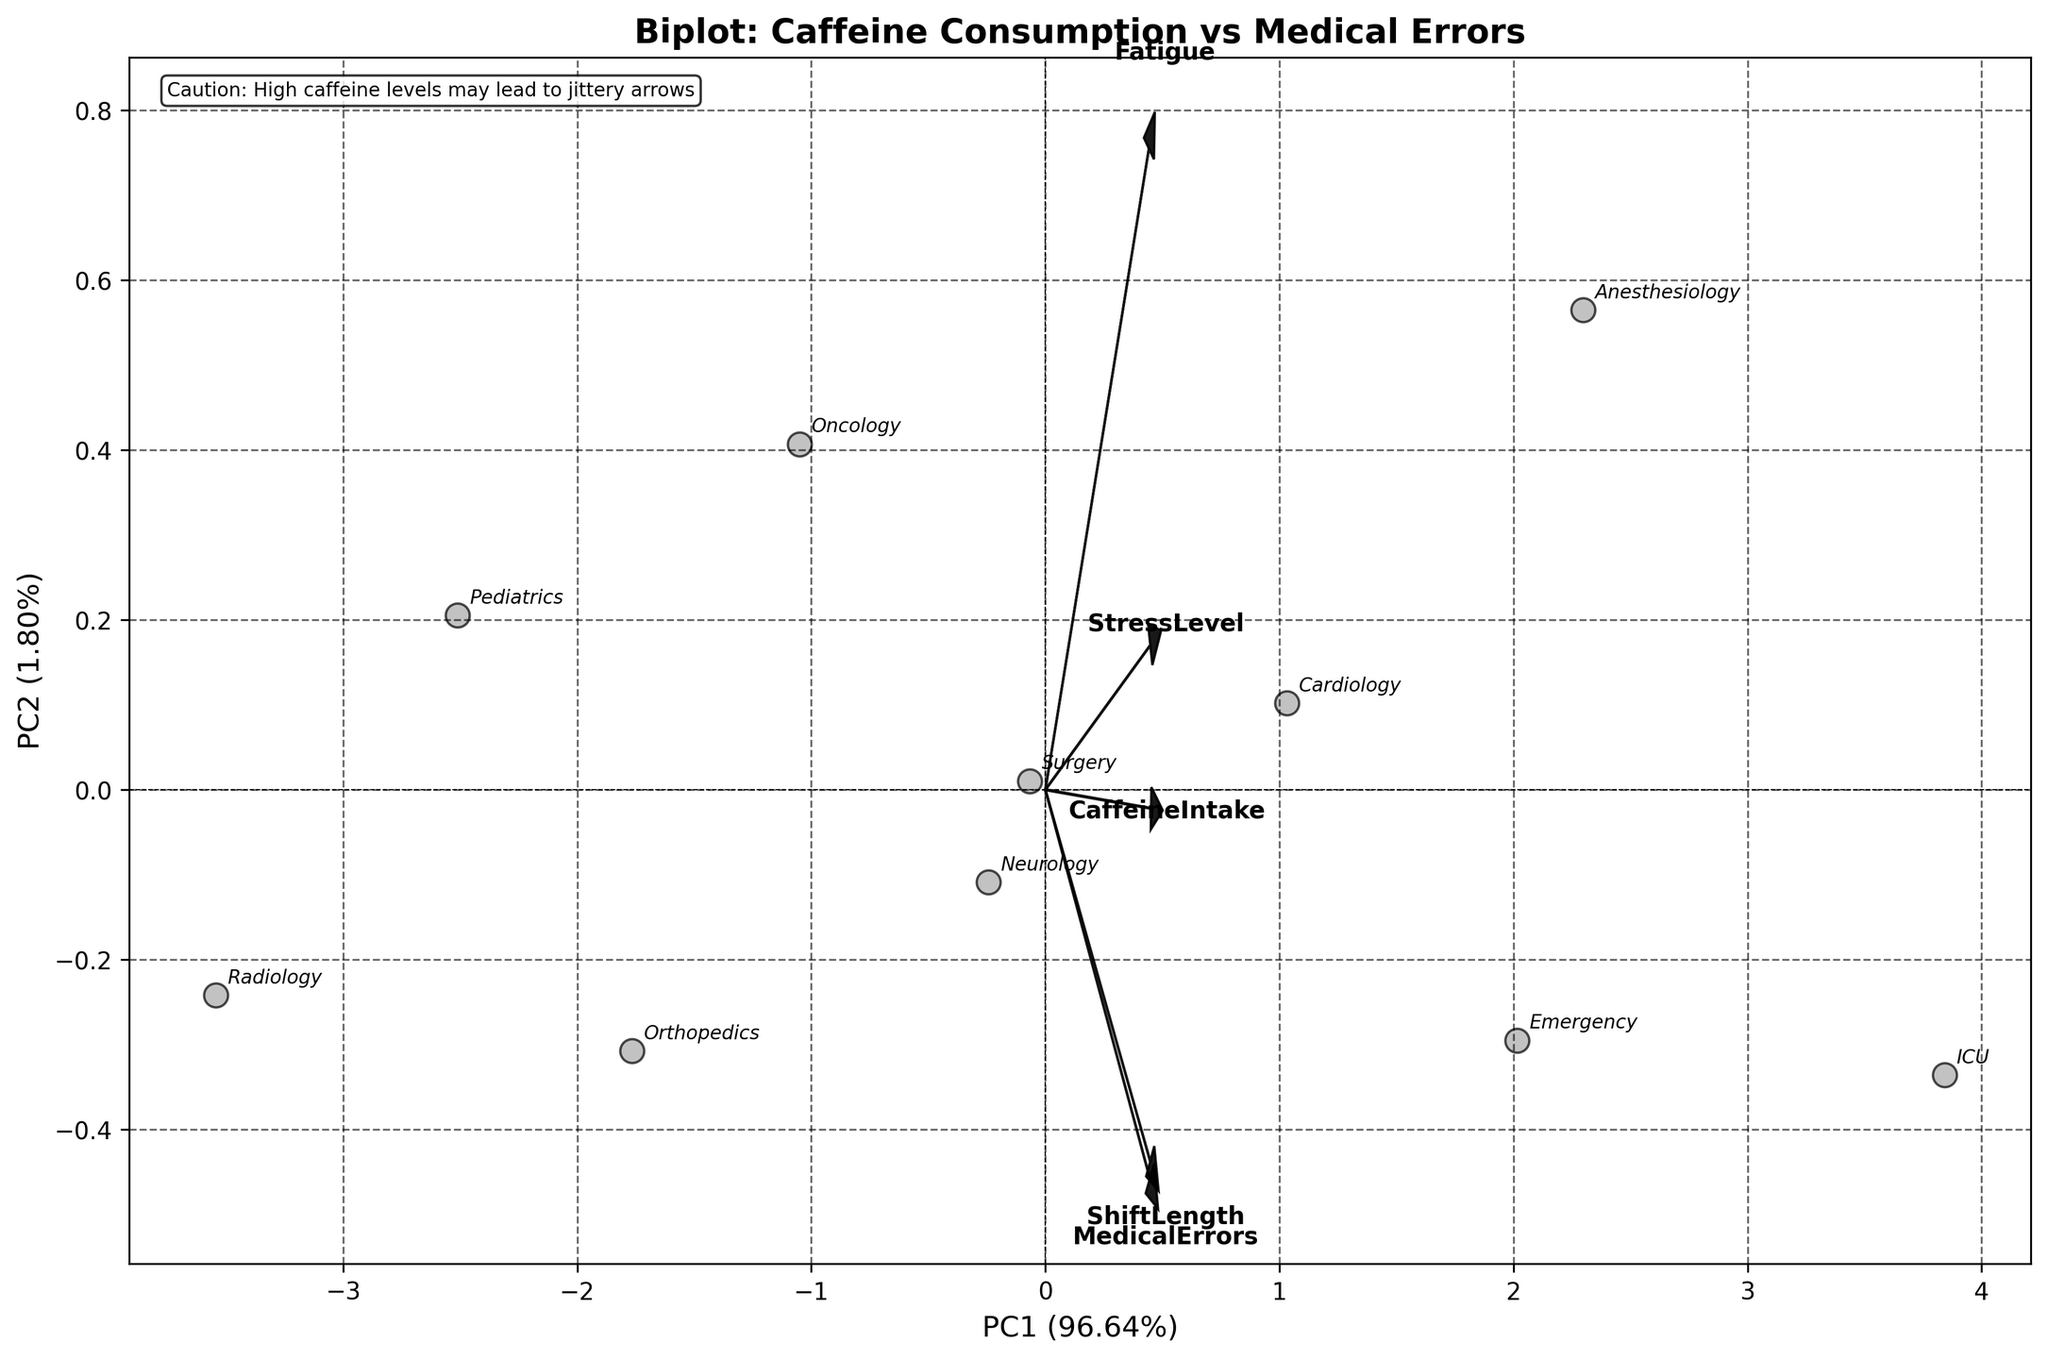Which department has the highest caffeine intake according to the biplot? Look at the position of the department labels on the PC1 and PC2 axes in relation to the caffeine intake variable vector's direction and length. The ICU department aligns most closely with the arrow for caffeine intake.
Answer: ICU What percentage of variance is explained by the first principal component (PC1)? The biplot's x-axis title indicates the percentage of variance explained by PC1.
Answer: 50% Which departments appear to have similar scores on the first principal component (PC1)? Look at the horizontal positions of the department labels along the PC1 axis; those close to each other on the x-axis have similar scores. Surgery, Neurology, and Emergency are clustered together.
Answer: Surgery, Neurology, Emergency How do "Medical Errors" correlate with "Stress Level" based on the biplot? Consider the angles between the medical errors and stress level vectors; a small angle indicates a positive correlation. The vectors align closely, indicating a strong positive correlation.
Answer: Strong positive correlation Which variable has the weakest influence on the principal components? Look at the length of the vectors representing each variable; shorter arrows indicate weaker influence. Fatigue has the shortest vector.
Answer: Fatigue Compare the placement of "Pediatrics" and "Radiology" on the biplot. Which department is associated with higher fatigue levels? Look at their positions in relation to the fatigue vector. Pediatrics is closer to the direction of the fatigue vector.
Answer: Pediatrics What is the observed relationship between "Shift Length" and "Medical Errors" according to the biplot? Analyze the angles between the shift length and medical errors vectors; a small angle between them suggests a positive correlation. The vectors are closely aligned, indicating a positive correlation.
Answer: Positive correlation How does "Stress Level" relate to "Caffeine Intake" in the biplot? Observe the vectors' directions for stress level and caffeine intake. They point in a similar direction, indicating a positive correlation.
Answer: Positive correlation Which department is most likely to have the highest rates of medical errors? Look at the position of department labels relative to the medical errors vector. ICU is most aligned with the medical errors arrow.
Answer: ICU What does the text "Caution: High caffeine levels may lead to jittery arrows" at the top of the plot suggest humorously? It humorously suggests that interpreting high caffeine intake might lead to overly excited or overinterpreted results due to caffeine's stimulating effects.
Answer: Interpretation caution due to caffeine 